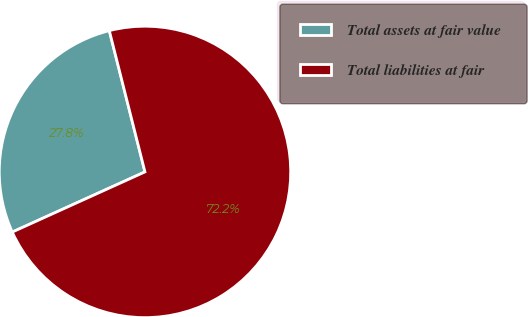Convert chart to OTSL. <chart><loc_0><loc_0><loc_500><loc_500><pie_chart><fcel>Total assets at fair value<fcel>Total liabilities at fair<nl><fcel>27.84%<fcel>72.16%<nl></chart> 